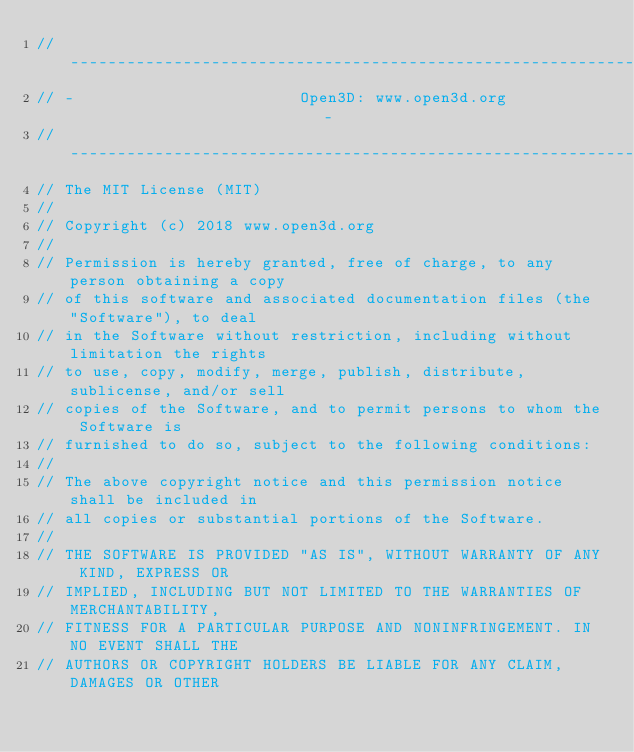Convert code to text. <code><loc_0><loc_0><loc_500><loc_500><_ObjectiveC_>// ----------------------------------------------------------------------------
// -                        Open3D: www.open3d.org                            -
// ----------------------------------------------------------------------------
// The MIT License (MIT)
//
// Copyright (c) 2018 www.open3d.org
//
// Permission is hereby granted, free of charge, to any person obtaining a copy
// of this software and associated documentation files (the "Software"), to deal
// in the Software without restriction, including without limitation the rights
// to use, copy, modify, merge, publish, distribute, sublicense, and/or sell
// copies of the Software, and to permit persons to whom the Software is
// furnished to do so, subject to the following conditions:
//
// The above copyright notice and this permission notice shall be included in
// all copies or substantial portions of the Software.
//
// THE SOFTWARE IS PROVIDED "AS IS", WITHOUT WARRANTY OF ANY KIND, EXPRESS OR
// IMPLIED, INCLUDING BUT NOT LIMITED TO THE WARRANTIES OF MERCHANTABILITY,
// FITNESS FOR A PARTICULAR PURPOSE AND NONINFRINGEMENT. IN NO EVENT SHALL THE
// AUTHORS OR COPYRIGHT HOLDERS BE LIABLE FOR ANY CLAIM, DAMAGES OR OTHER</code> 